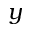<formula> <loc_0><loc_0><loc_500><loc_500>y</formula> 